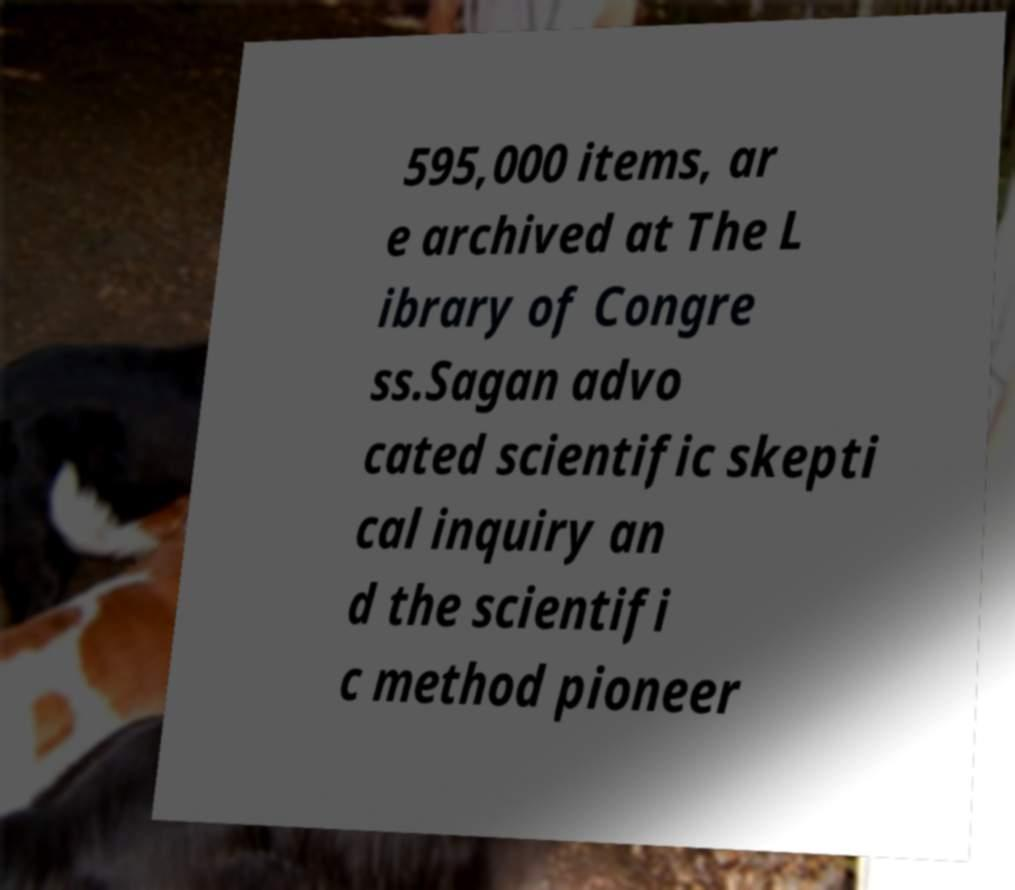Could you assist in decoding the text presented in this image and type it out clearly? 595,000 items, ar e archived at The L ibrary of Congre ss.Sagan advo cated scientific skepti cal inquiry an d the scientifi c method pioneer 